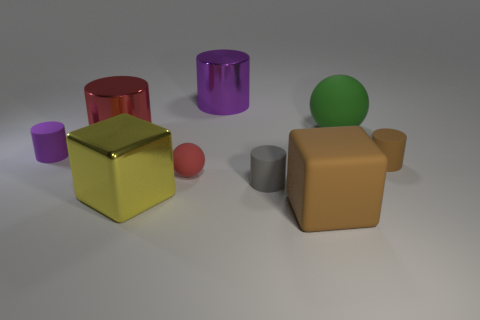Subtract all purple matte cylinders. How many cylinders are left? 4 Subtract all purple cubes. How many purple cylinders are left? 2 Add 1 large rubber objects. How many objects exist? 10 Subtract all balls. How many objects are left? 7 Subtract 2 cylinders. How many cylinders are left? 3 Add 2 gray things. How many gray things are left? 3 Add 2 small red rubber spheres. How many small red rubber spheres exist? 3 Subtract all gray cylinders. How many cylinders are left? 4 Subtract 1 red cylinders. How many objects are left? 8 Subtract all blue cylinders. Subtract all green blocks. How many cylinders are left? 5 